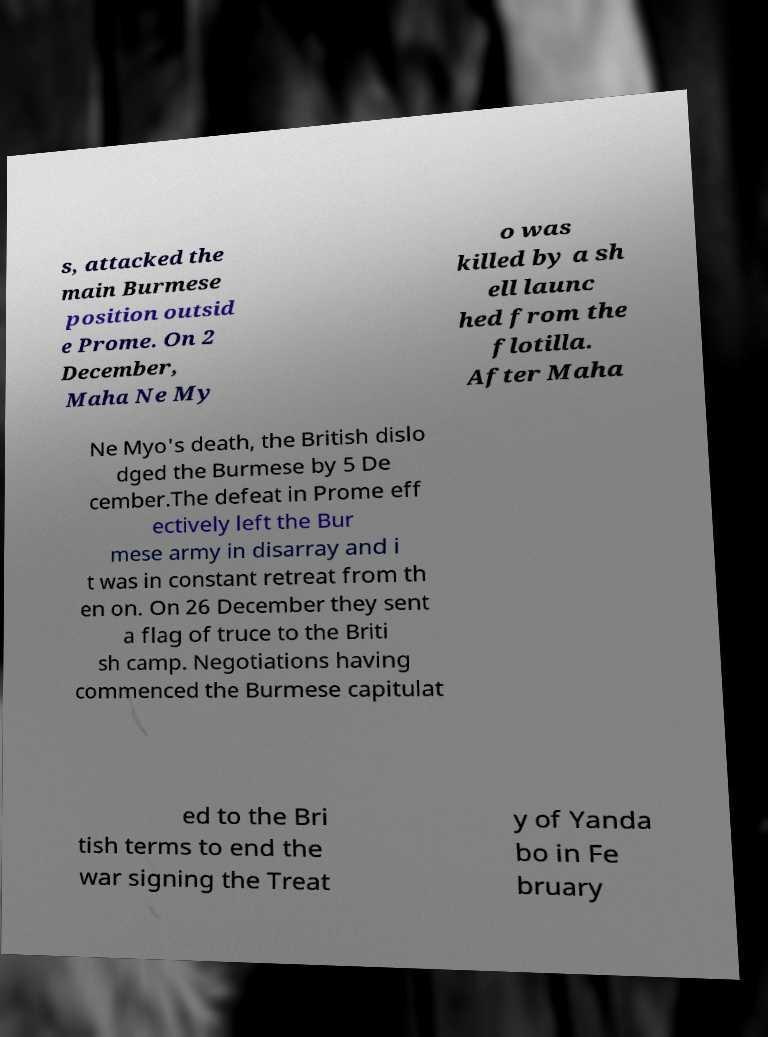What messages or text are displayed in this image? I need them in a readable, typed format. s, attacked the main Burmese position outsid e Prome. On 2 December, Maha Ne My o was killed by a sh ell launc hed from the flotilla. After Maha Ne Myo's death, the British dislo dged the Burmese by 5 De cember.The defeat in Prome eff ectively left the Bur mese army in disarray and i t was in constant retreat from th en on. On 26 December they sent a flag of truce to the Briti sh camp. Negotiations having commenced the Burmese capitulat ed to the Bri tish terms to end the war signing the Treat y of Yanda bo in Fe bruary 